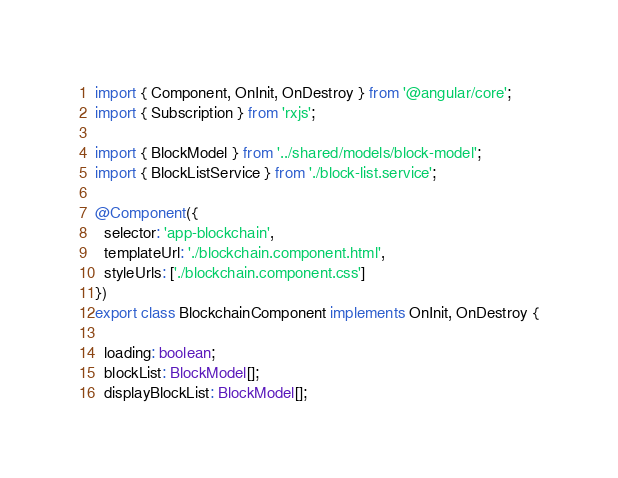<code> <loc_0><loc_0><loc_500><loc_500><_TypeScript_>import { Component, OnInit, OnDestroy } from '@angular/core';
import { Subscription } from 'rxjs';

import { BlockModel } from '../shared/models/block-model';
import { BlockListService } from './block-list.service';

@Component({
  selector: 'app-blockchain',
  templateUrl: './blockchain.component.html',
  styleUrls: ['./blockchain.component.css']
})
export class BlockchainComponent implements OnInit, OnDestroy {

  loading: boolean;
  blockList: BlockModel[];
  displayBlockList: BlockModel[];</code> 